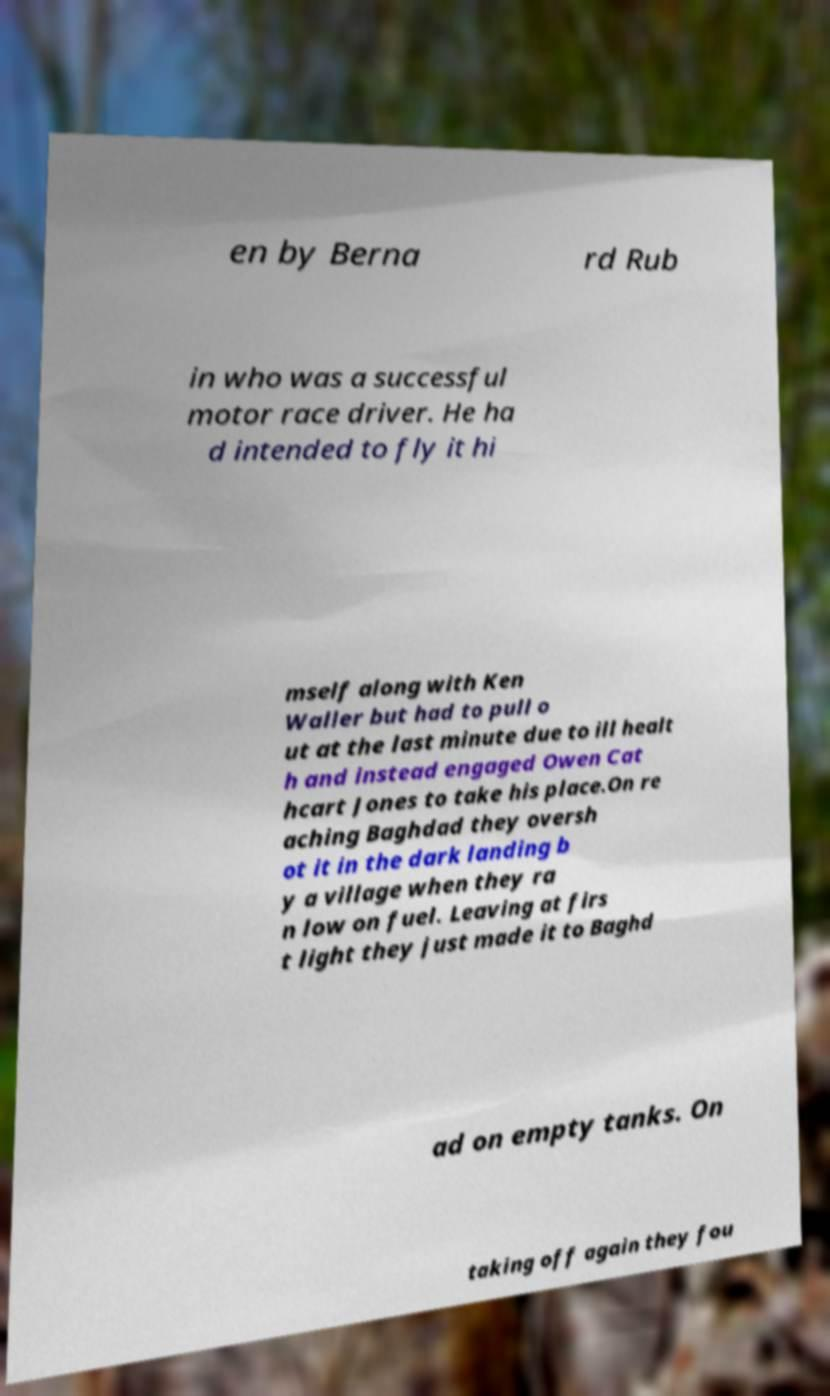Could you extract and type out the text from this image? en by Berna rd Rub in who was a successful motor race driver. He ha d intended to fly it hi mself along with Ken Waller but had to pull o ut at the last minute due to ill healt h and instead engaged Owen Cat hcart Jones to take his place.On re aching Baghdad they oversh ot it in the dark landing b y a village when they ra n low on fuel. Leaving at firs t light they just made it to Baghd ad on empty tanks. On taking off again they fou 